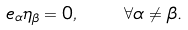Convert formula to latex. <formula><loc_0><loc_0><loc_500><loc_500>e _ { \alpha } \eta _ { \beta } = 0 , \quad \forall \alpha \neq \beta .</formula> 